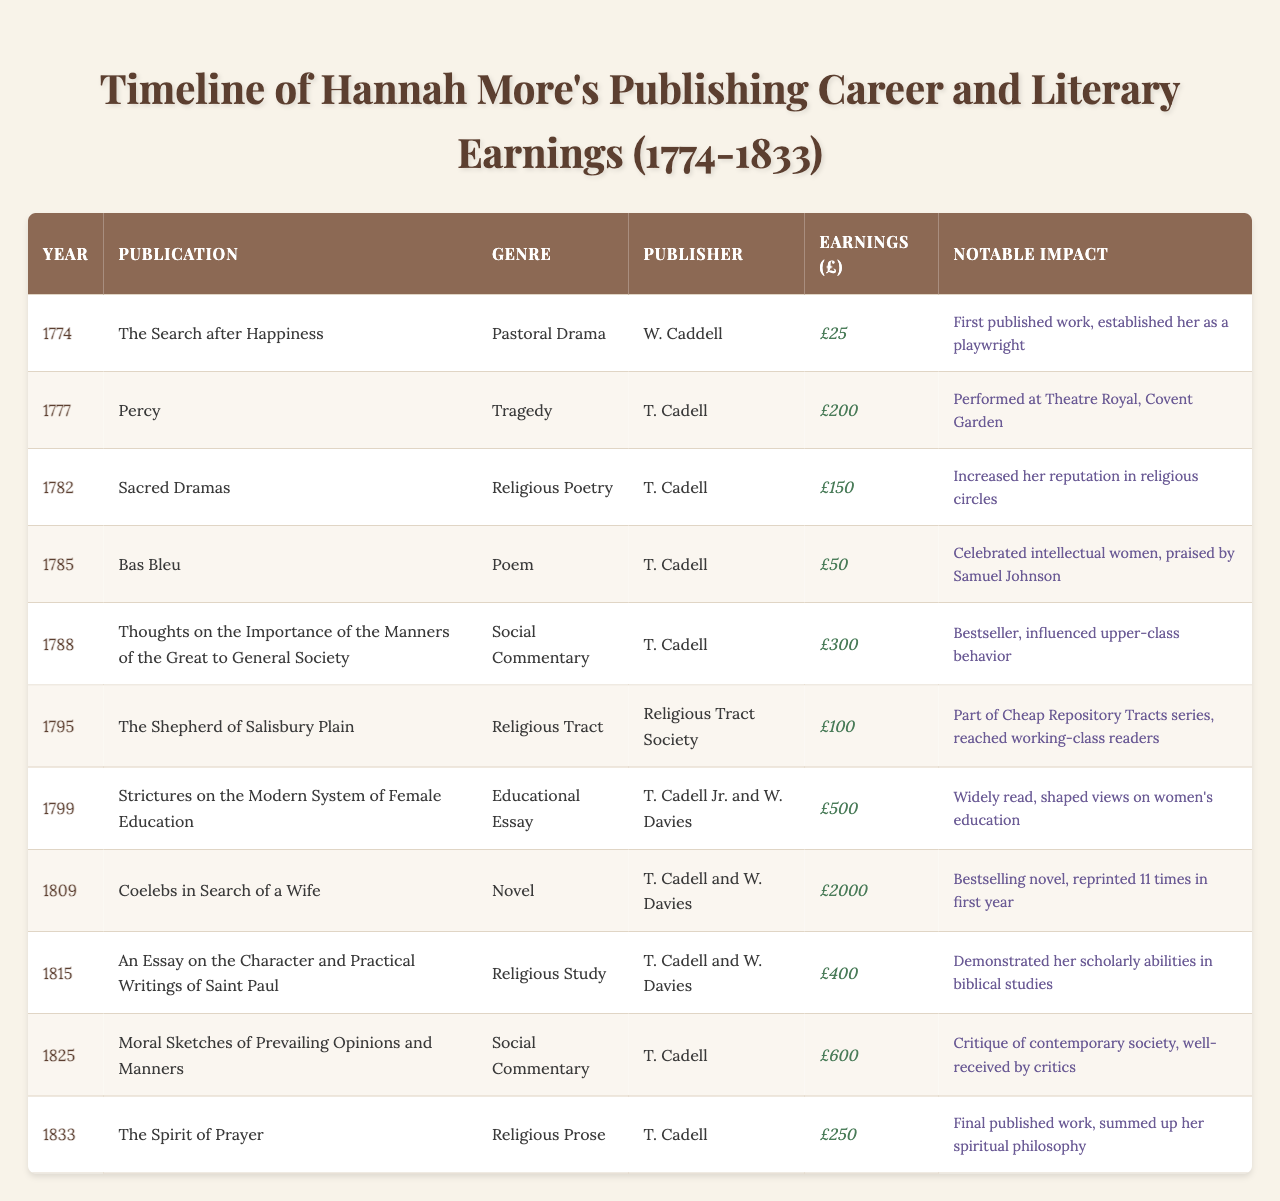What was the highest earning year for Hannah More? The highest earnings recorded in the table is £2000 from the year 1809 for the publication "Coelebs in Search of a Wife." Thus, the highest earning year is 1809.
Answer: 1809 What impact did "The Shepherd of Salisbury Plain" have? According to the table, "The Shepherd of Salisbury Plain" was part of the Cheap Repository Tracts series and reached working-class readers. This indicates its aim to communicate with and uplift the lower social classes.
Answer: Reached working-class readers How much did Hannah More earn in total from her publications listed in the table? Adding all the earnings from each year (25 + 200 + 150 + 50 + 300 + 100 + 500 + 2000 + 400 + 600 + 250) gives a total of £4175. Therefore, the total earnings from her publications are £4175.
Answer: £4175 Was "Strictures on the Modern System of Female Education" influential? Yes, this publication is noted in the table as widely read and having shaped views on women's education, indicating its significant influence.
Answer: Yes How does the average earning compare to the highest earning from a single publication? The average earning is calculated by dividing the total earnings (£4175) by the number of publications (11), yielding £379.55. The highest earning from a single publication is £2000 from "Coelebs in Search of a Wife." This shows that the average is significantly lower than the highest earning.
Answer: Average is £379.55; highest is £2000 Which publication had the genre of "Poem"? The table indicates that "Bas Bleu," published in 1785, falls under the genre of Poem. This is the only entry of its kind in the provided data.
Answer: "Bas Bleu" What was the notable impact of "Thoughts on the Importance of the Manners of the Great to General Society"? This publication was a bestseller and influenced upper-class behavior, as stated in the notable impact column. This shows its significant societal impact.
Answer: Influenced upper-class behavior In what year did Hannah More first achieve notable literary earnings? The first notable earnings recorded is from the year 1777 with "Percy," which earned £200. This marks her entry into significant literary accomplishment.
Answer: 1777 Did Hannah More publish any work in the 1820s? Yes, the table lists "Moral Sketches of Prevailing Opinions and Manners," published in 1825, indicating that she did publish during the 1820s.
Answer: Yes How many publications discussed educational themes? The table includes two publications with educational themes: "Strictures on the Modern System of Female Education" and "An Essay on the Character and Practical Writings of Saint Paul," amounting to two educational works.
Answer: Two publications Which work discussed religious themes and was published last? "The Spirit of Prayer," published in 1833, is the last entry in the table that discusses religious themes. It sums up her spiritual philosophy, as noted in the impact column.
Answer: "The Spirit of Prayer" 